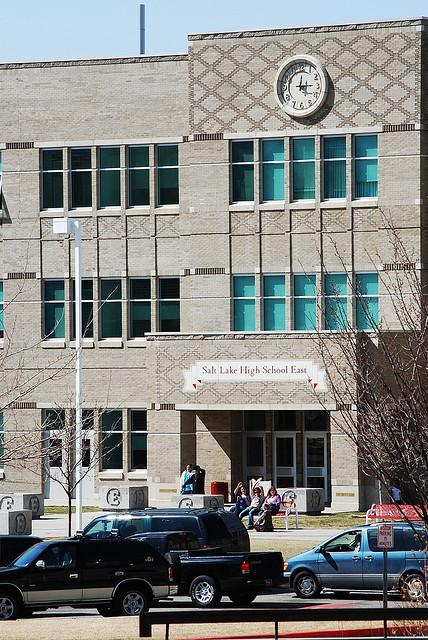What age people mostly utilize this space? Please explain your reasoning. teens. Teens use the space. 